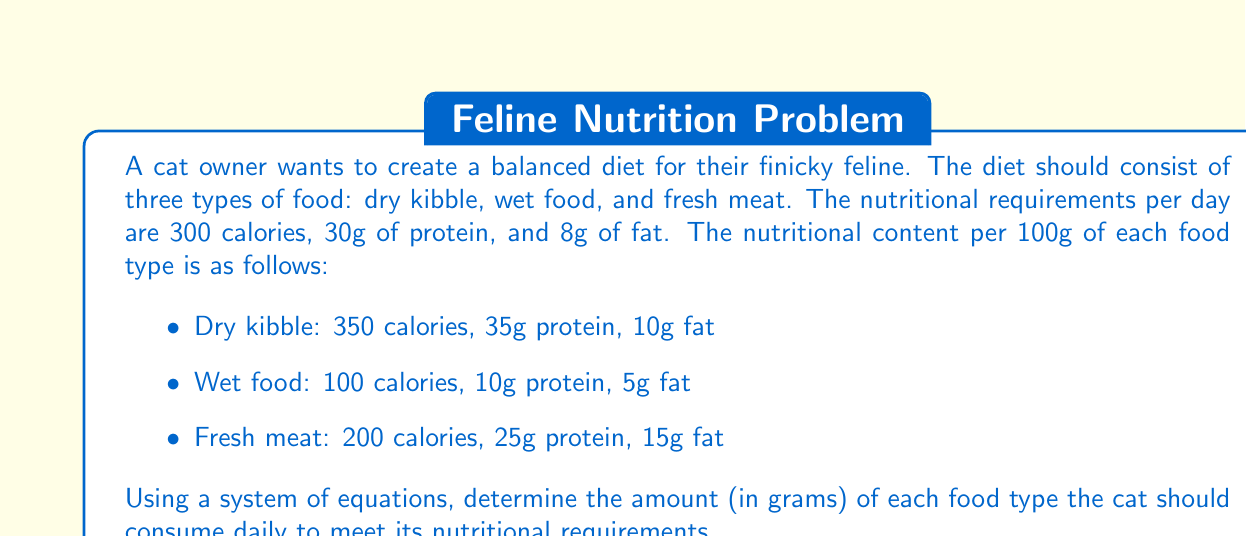What is the answer to this math problem? Let's approach this step-by-step:

1) Let $x$, $y$, and $z$ represent the amount (in grams) of dry kibble, wet food, and fresh meat, respectively.

2) We can set up a system of three equations based on the nutritional requirements:

   Calories: $3.5x + y + 2z = 300$
   Protein: $0.35x + 0.1y + 0.25z = 30$
   Fat: $0.1x + 0.05y + 0.15z = 8$

3) To solve this system, let's use the elimination method:

4) Multiply the second equation by 10 and the third equation by 100:

   $3.5x + y + 2z = 300$
   $3.5x + y + 2.5z = 300$
   $10x + 5y + 15z = 800$

5) Subtract the first equation from the second:

   $0.5z = 0$
   $z = 0$

6) Substitute $z = 0$ into the first two equations:

   $3.5x + y = 300$
   $0.35x + 0.1y = 30$

7) Multiply the second equation by 10:

   $3.5x + y = 300$
   $3.5x + y = 300$

8) Subtract these equations:

   $0 = 0$

   This means the equations are dependent, and we have infinite solutions.

9) Let's express $y$ in terms of $x$:

   $y = 300 - 3.5x$

10) Substitute this into the protein equation:

    $0.35x + 0.1(300 - 3.5x) = 30$
    $0.35x + 30 - 0.35x = 30$
    $30 = 30$

This confirms that we have infinite solutions. To find a practical solution, we can choose a reasonable value for $x$ (dry kibble), as it's typically the base of a cat's diet.

Let's choose $x = 60$ (60g of dry kibble):

$y = 300 - 3.5(60) = 90$ (90g of wet food)
$z = 0$ (0g of fresh meat)

We can verify that this solution satisfies all nutritional requirements:

Calories: $3.5(60) + 1(90) + 2(0) = 300$
Protein: $0.35(60) + 0.1(90) + 0.25(0) = 30$
Fat: $0.1(60) + 0.05(90) + 0.15(0) = 8$
Answer: 60g dry kibble, 90g wet food, 0g fresh meat 